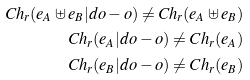Convert formula to latex. <formula><loc_0><loc_0><loc_500><loc_500>C h _ { r } ( e _ { A } \uplus e _ { B } | d o - o ) \neq C h _ { r } ( e _ { A } \uplus e _ { B } ) \\ C h _ { r } ( e _ { A } | d o - o ) \neq C h _ { r } ( e _ { A } ) \\ C h _ { r } ( e _ { B } | d o - o ) \neq C h _ { r } ( e _ { B } )</formula> 